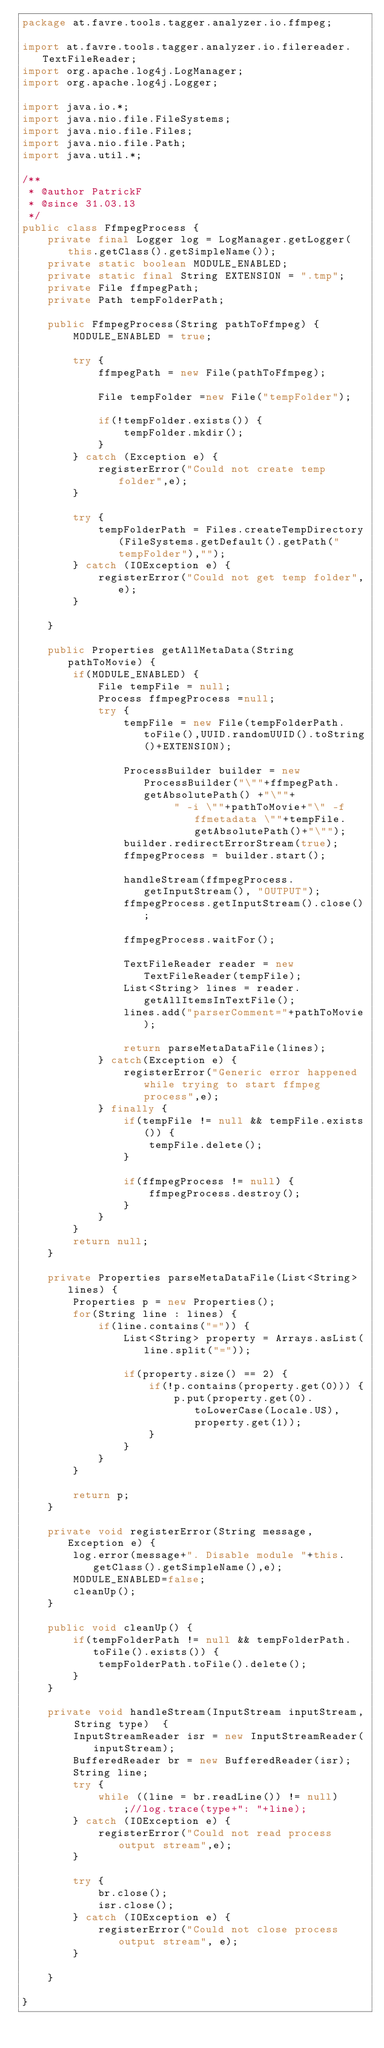<code> <loc_0><loc_0><loc_500><loc_500><_Java_>package at.favre.tools.tagger.analyzer.io.ffmpeg;

import at.favre.tools.tagger.analyzer.io.filereader.TextFileReader;
import org.apache.log4j.LogManager;
import org.apache.log4j.Logger;

import java.io.*;
import java.nio.file.FileSystems;
import java.nio.file.Files;
import java.nio.file.Path;
import java.util.*;

/**
 * @author PatrickF
 * @since 31.03.13
 */
public class FfmpegProcess {
	private final Logger log = LogManager.getLogger(this.getClass().getSimpleName());
	private static boolean MODULE_ENABLED;
	private static final String EXTENSION = ".tmp";
	private File ffmpegPath;
	private Path tempFolderPath;

	public FfmpegProcess(String pathToFfmpeg) {
		MODULE_ENABLED = true;

		try {
			ffmpegPath = new File(pathToFfmpeg);

			File tempFolder =new File("tempFolder");

			if(!tempFolder.exists()) {
				tempFolder.mkdir();
			}
		} catch (Exception e) {
			registerError("Could not create temp folder",e);
		}

		try {
			tempFolderPath = Files.createTempDirectory(FileSystems.getDefault().getPath("tempFolder"),"");
		} catch (IOException e) {
			registerError("Could not get temp folder",e);
		}

	}

	public Properties getAllMetaData(String pathToMovie) {
		if(MODULE_ENABLED) {
			File tempFile = null;
			Process ffmpegProcess =null;
			try {
				tempFile = new File(tempFolderPath.toFile(),UUID.randomUUID().toString()+EXTENSION);

				ProcessBuilder builder = new ProcessBuilder("\""+ffmpegPath.getAbsolutePath() +"\""+
						" -i \""+pathToMovie+"\" -f ffmetadata \""+tempFile.getAbsolutePath()+"\"");
				builder.redirectErrorStream(true);
				ffmpegProcess = builder.start();

				handleStream(ffmpegProcess.getInputStream(), "OUTPUT");
				ffmpegProcess.getInputStream().close();

				ffmpegProcess.waitFor();

				TextFileReader reader = new TextFileReader(tempFile);
				List<String> lines = reader.getAllItemsInTextFile();
				lines.add("parserComment="+pathToMovie);

				return parseMetaDataFile(lines);
			} catch(Exception e) {
				registerError("Generic error happened while trying to start ffmpeg process",e);
			} finally {
				if(tempFile != null && tempFile.exists()) {
					tempFile.delete();
				}

				if(ffmpegProcess != null) {
					ffmpegProcess.destroy();
				}
			}
		}
		return null;
	}

	private Properties parseMetaDataFile(List<String> lines) {
		Properties p = new Properties();
		for(String line : lines) {
			if(line.contains("=")) {
				List<String> property = Arrays.asList(line.split("="));

				if(property.size() == 2) {
					if(!p.contains(property.get(0))) {
						p.put(property.get(0).toLowerCase(Locale.US),property.get(1));
					}
				}
			}
		}

		return p;
	}

	private void registerError(String message, Exception e) {
		log.error(message+". Disable module "+this.getClass().getSimpleName(),e);
		MODULE_ENABLED=false;
		cleanUp();
	}

	public void cleanUp() {
		if(tempFolderPath != null && tempFolderPath.toFile().exists()) {
			tempFolderPath.toFile().delete();
		}
	}

	private void handleStream(InputStream inputStream, String type)  {
		InputStreamReader isr = new InputStreamReader(inputStream);
		BufferedReader br = new BufferedReader(isr);
		String line;
		try {
			while ((line = br.readLine()) != null)
				;//log.trace(type+": "+line);
		} catch (IOException e) {
			registerError("Could not read process output stream",e);
		}

		try {
			br.close();
			isr.close();
		} catch (IOException e) {
			registerError("Could not close process output stream", e);
		}

	}

}
</code> 